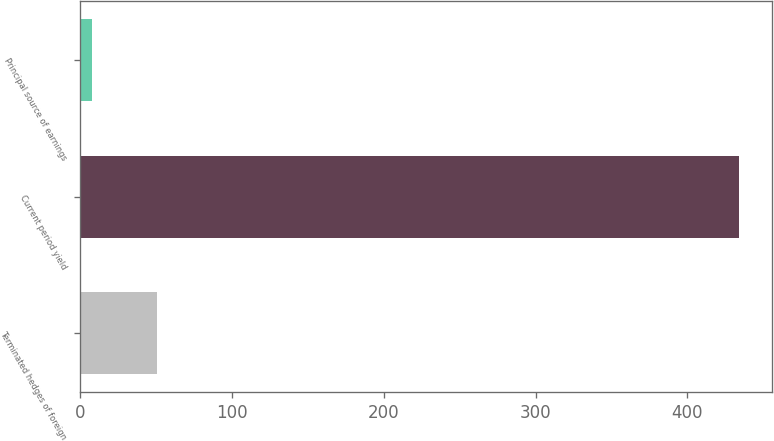Convert chart to OTSL. <chart><loc_0><loc_0><loc_500><loc_500><bar_chart><fcel>Terminated hedges of foreign<fcel>Current period yield<fcel>Principal source of earnings<nl><fcel>50.6<fcel>434<fcel>8<nl></chart> 